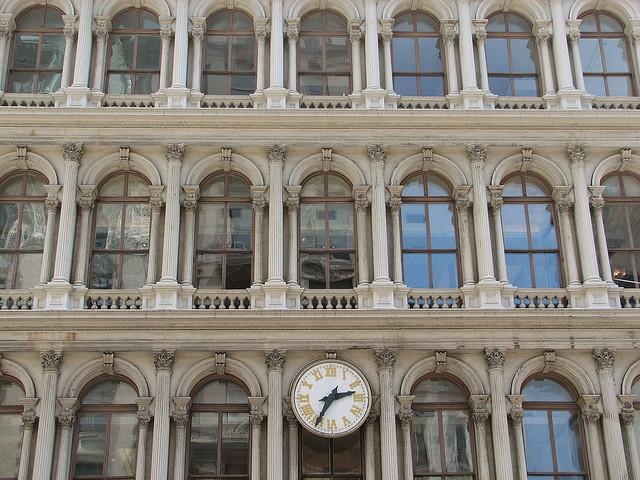What shape are the windows?
Write a very short answer. Arched. What shape is the clock?
Be succinct. Round. What type of numbers are on the clock?
Give a very brief answer. Roman. 